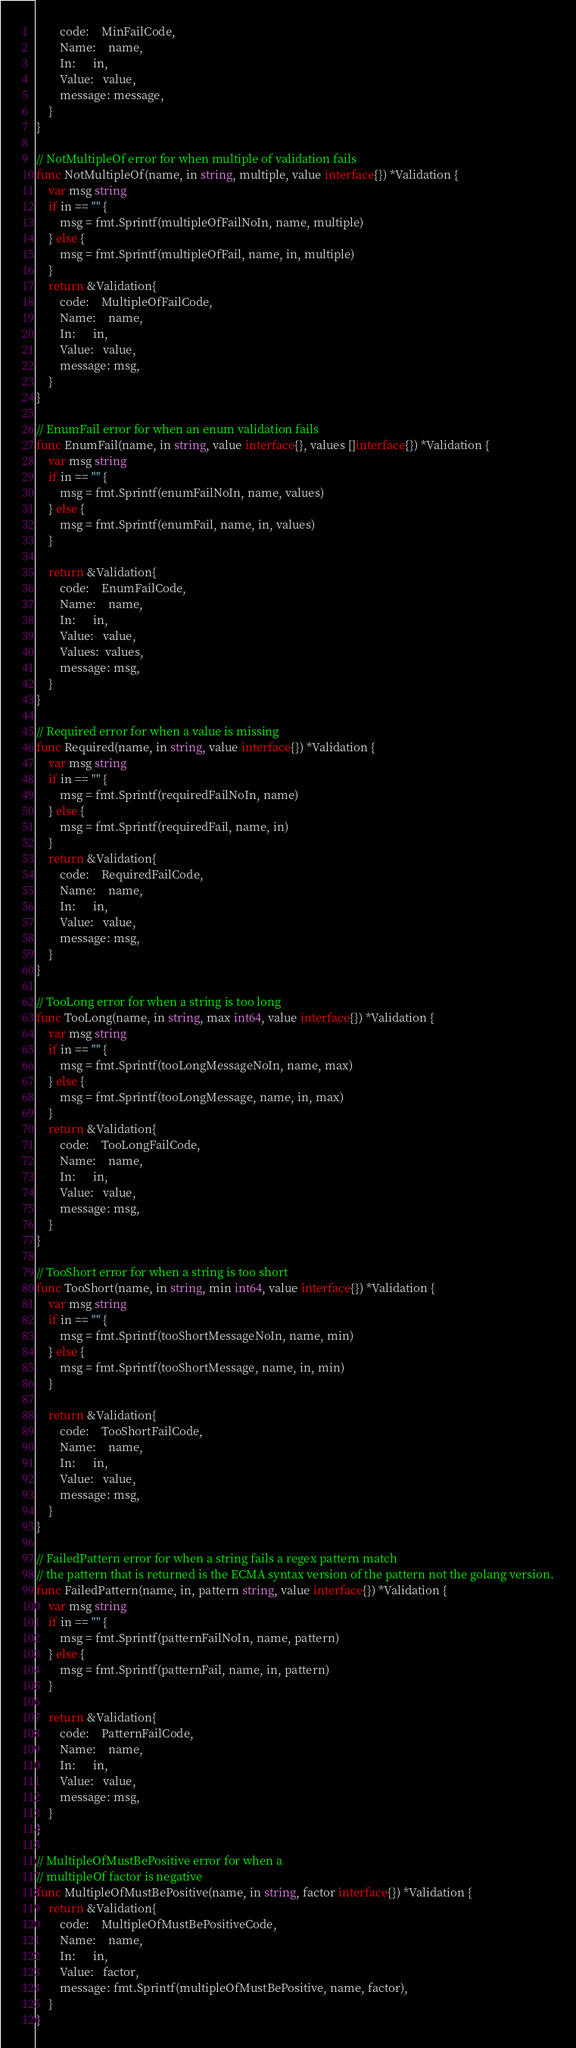<code> <loc_0><loc_0><loc_500><loc_500><_Go_>		code:    MinFailCode,
		Name:    name,
		In:      in,
		Value:   value,
		message: message,
	}
}

// NotMultipleOf error for when multiple of validation fails
func NotMultipleOf(name, in string, multiple, value interface{}) *Validation {
	var msg string
	if in == "" {
		msg = fmt.Sprintf(multipleOfFailNoIn, name, multiple)
	} else {
		msg = fmt.Sprintf(multipleOfFail, name, in, multiple)
	}
	return &Validation{
		code:    MultipleOfFailCode,
		Name:    name,
		In:      in,
		Value:   value,
		message: msg,
	}
}

// EnumFail error for when an enum validation fails
func EnumFail(name, in string, value interface{}, values []interface{}) *Validation {
	var msg string
	if in == "" {
		msg = fmt.Sprintf(enumFailNoIn, name, values)
	} else {
		msg = fmt.Sprintf(enumFail, name, in, values)
	}

	return &Validation{
		code:    EnumFailCode,
		Name:    name,
		In:      in,
		Value:   value,
		Values:  values,
		message: msg,
	}
}

// Required error for when a value is missing
func Required(name, in string, value interface{}) *Validation {
	var msg string
	if in == "" {
		msg = fmt.Sprintf(requiredFailNoIn, name)
	} else {
		msg = fmt.Sprintf(requiredFail, name, in)
	}
	return &Validation{
		code:    RequiredFailCode,
		Name:    name,
		In:      in,
		Value:   value,
		message: msg,
	}
}

// TooLong error for when a string is too long
func TooLong(name, in string, max int64, value interface{}) *Validation {
	var msg string
	if in == "" {
		msg = fmt.Sprintf(tooLongMessageNoIn, name, max)
	} else {
		msg = fmt.Sprintf(tooLongMessage, name, in, max)
	}
	return &Validation{
		code:    TooLongFailCode,
		Name:    name,
		In:      in,
		Value:   value,
		message: msg,
	}
}

// TooShort error for when a string is too short
func TooShort(name, in string, min int64, value interface{}) *Validation {
	var msg string
	if in == "" {
		msg = fmt.Sprintf(tooShortMessageNoIn, name, min)
	} else {
		msg = fmt.Sprintf(tooShortMessage, name, in, min)
	}

	return &Validation{
		code:    TooShortFailCode,
		Name:    name,
		In:      in,
		Value:   value,
		message: msg,
	}
}

// FailedPattern error for when a string fails a regex pattern match
// the pattern that is returned is the ECMA syntax version of the pattern not the golang version.
func FailedPattern(name, in, pattern string, value interface{}) *Validation {
	var msg string
	if in == "" {
		msg = fmt.Sprintf(patternFailNoIn, name, pattern)
	} else {
		msg = fmt.Sprintf(patternFail, name, in, pattern)
	}

	return &Validation{
		code:    PatternFailCode,
		Name:    name,
		In:      in,
		Value:   value,
		message: msg,
	}
}

// MultipleOfMustBePositive error for when a
// multipleOf factor is negative
func MultipleOfMustBePositive(name, in string, factor interface{}) *Validation {
	return &Validation{
		code:    MultipleOfMustBePositiveCode,
		Name:    name,
		In:      in,
		Value:   factor,
		message: fmt.Sprintf(multipleOfMustBePositive, name, factor),
	}
}
</code> 